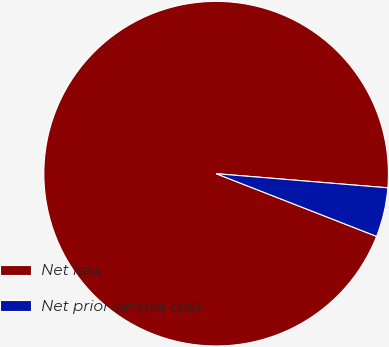Convert chart to OTSL. <chart><loc_0><loc_0><loc_500><loc_500><pie_chart><fcel>Net loss<fcel>Net prior service cost<nl><fcel>95.38%<fcel>4.62%<nl></chart> 